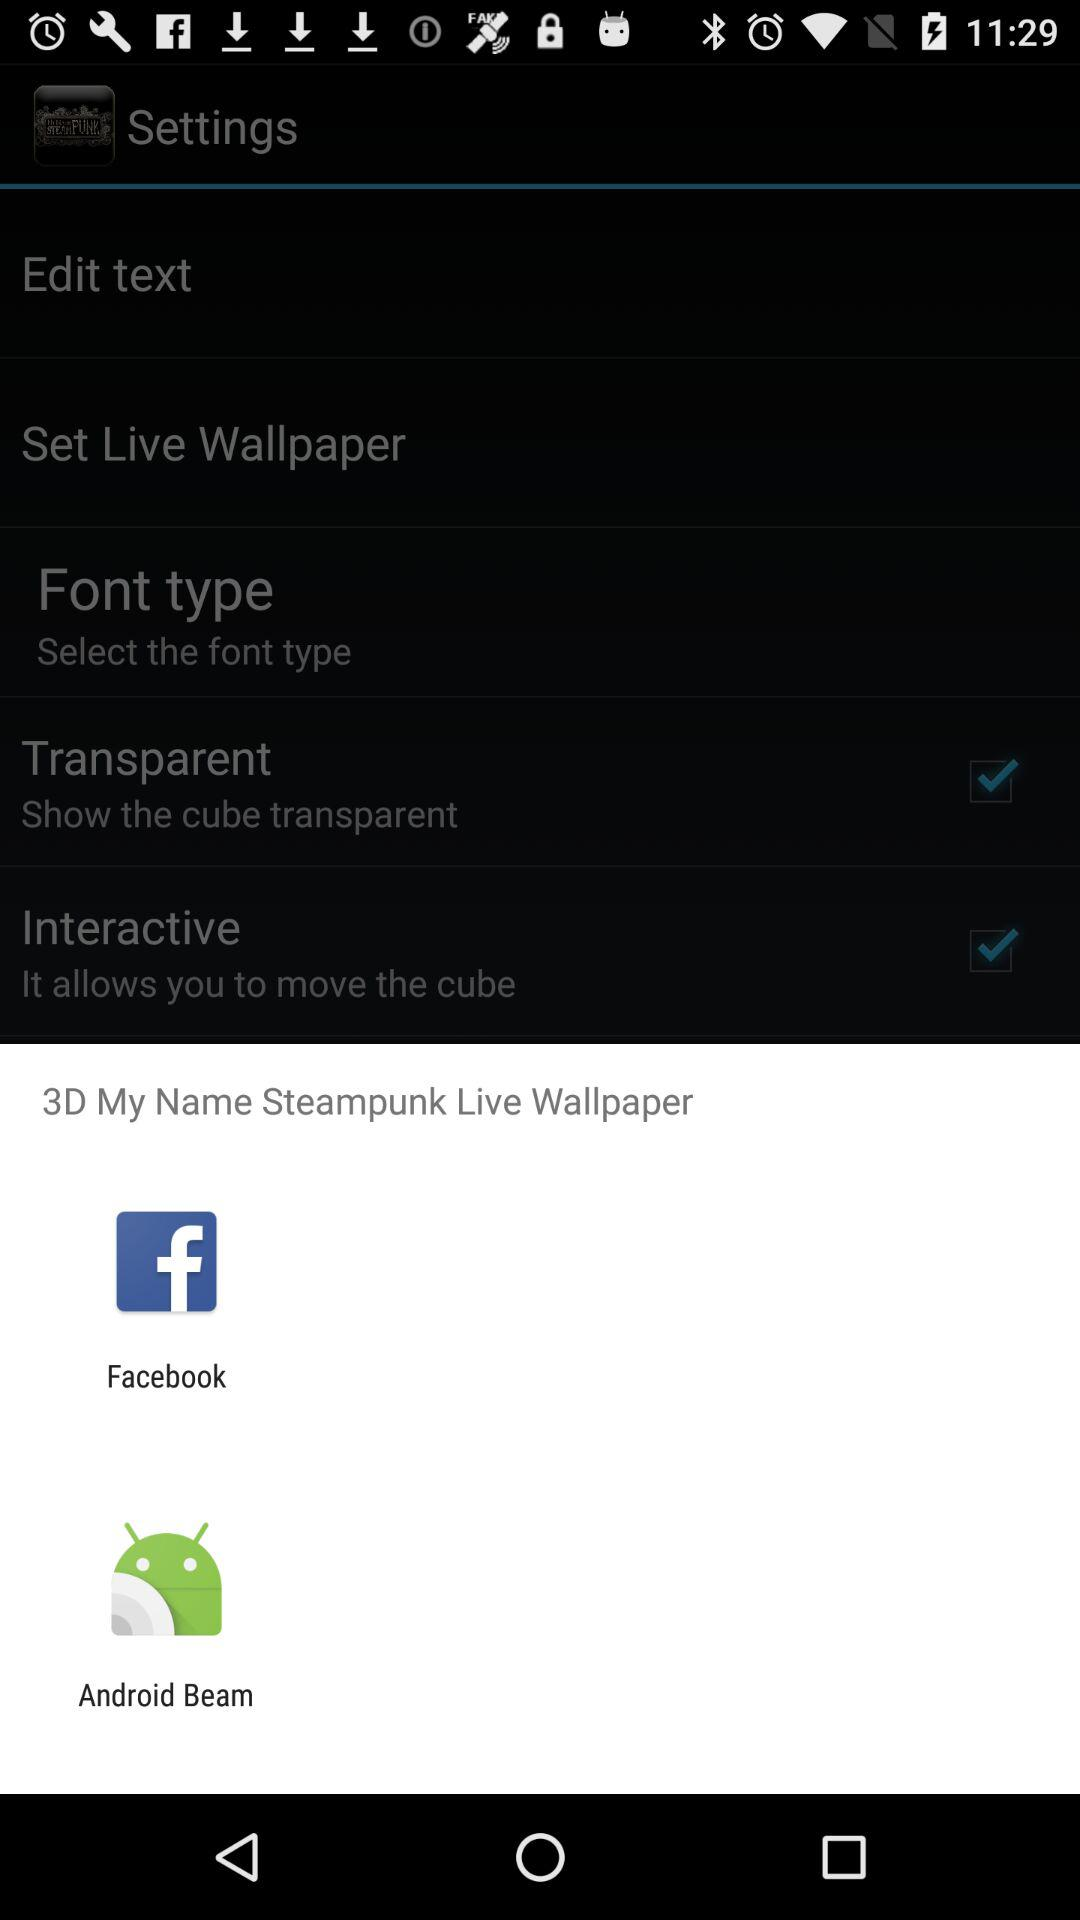How many check boxes are there in the settings menu?
Answer the question using a single word or phrase. 2 